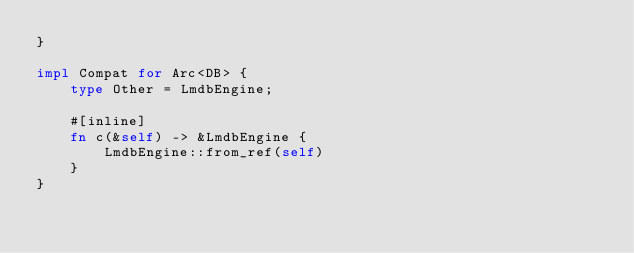<code> <loc_0><loc_0><loc_500><loc_500><_Rust_>}

impl Compat for Arc<DB> {
    type Other = LmdbEngine;

    #[inline]
    fn c(&self) -> &LmdbEngine {
        LmdbEngine::from_ref(self)
    }
}
</code> 